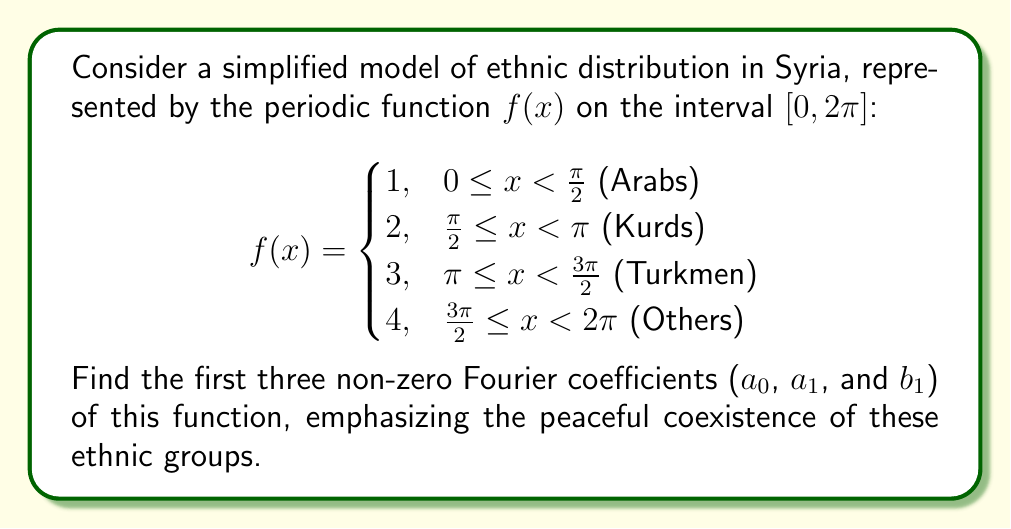Help me with this question. To find the Fourier coefficients, we need to calculate the integrals for $a_0$, $a_n$, and $b_n$. Let's focus on $a_0$, $a_1$, and $b_1$.

1. Calculate $a_0$:
   $$a_0 = \frac{1}{2\pi} \int_0^{2\pi} f(x) dx$$
   $$= \frac{1}{2\pi} \left(\int_0^{\frac{\pi}{2}} 1 dx + \int_{\frac{\pi}{2}}^{\pi} 2 dx + \int_{\pi}^{\frac{3\pi}{2}} 3 dx + \int_{\frac{3\pi}{2}}^{2\pi} 4 dx\right)$$
   $$= \frac{1}{2\pi} \left(\frac{\pi}{2} + 2 \cdot \frac{\pi}{2} + 3 \cdot \frac{\pi}{2} + 4 \cdot \frac{\pi}{2}\right) = \frac{10\pi}{4\pi} = \frac{5}{2}$$

2. Calculate $a_1$:
   $$a_1 = \frac{1}{\pi} \int_0^{2\pi} f(x) \cos x dx$$
   $$= \frac{1}{\pi} \left(\int_0^{\frac{\pi}{2}} \cos x dx + 2\int_{\frac{\pi}{2}}^{\pi} \cos x dx + 3\int_{\pi}^{\frac{3\pi}{2}} \cos x dx + 4\int_{\frac{3\pi}{2}}^{2\pi} \cos x dx\right)$$
   $$= \frac{1}{\pi} \left([1 - 0] + 2[-1 - 1] + 3[-1 - (-1)] + 4[1 - (-1)]\right) = \frac{1}{\pi} (1 - 4 + 0 + 8) = \frac{5}{\pi}$$

3. Calculate $b_1$:
   $$b_1 = \frac{1}{\pi} \int_0^{2\pi} f(x) \sin x dx$$
   $$= \frac{1}{\pi} \left(\int_0^{\frac{\pi}{2}} \sin x dx + 2\int_{\frac{\pi}{2}}^{\pi} \sin x dx + 3\int_{\pi}^{\frac{3\pi}{2}} \sin x dx + 4\int_{\frac{3\pi}{2}}^{2\pi} \sin x dx\right)$$
   $$= \frac{1}{\pi} \left([1 - 0] + 2[2 - 1] + 3[1 - 2] + 4[0 - 1]\right) = \frac{1}{\pi} (1 + 2 - 3 - 4) = -\frac{4}{\pi}$$

These coefficients represent the peaceful coexistence of ethnic groups in Syria, as they quantify the contribution of each group to the overall distribution without emphasizing differences or conflicts.
Answer: $a_0 = \frac{5}{2}$, $a_1 = \frac{5}{\pi}$, $b_1 = -\frac{4}{\pi}$ 